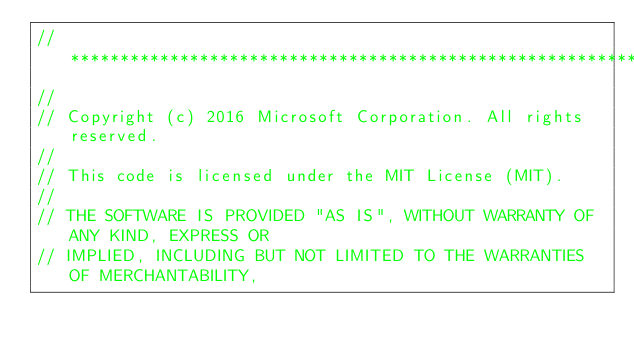Convert code to text. <code><loc_0><loc_0><loc_500><loc_500><_ObjectiveC_>//******************************************************************************
//
// Copyright (c) 2016 Microsoft Corporation. All rights reserved.
//
// This code is licensed under the MIT License (MIT).
//
// THE SOFTWARE IS PROVIDED "AS IS", WITHOUT WARRANTY OF ANY KIND, EXPRESS OR
// IMPLIED, INCLUDING BUT NOT LIMITED TO THE WARRANTIES OF MERCHANTABILITY,</code> 